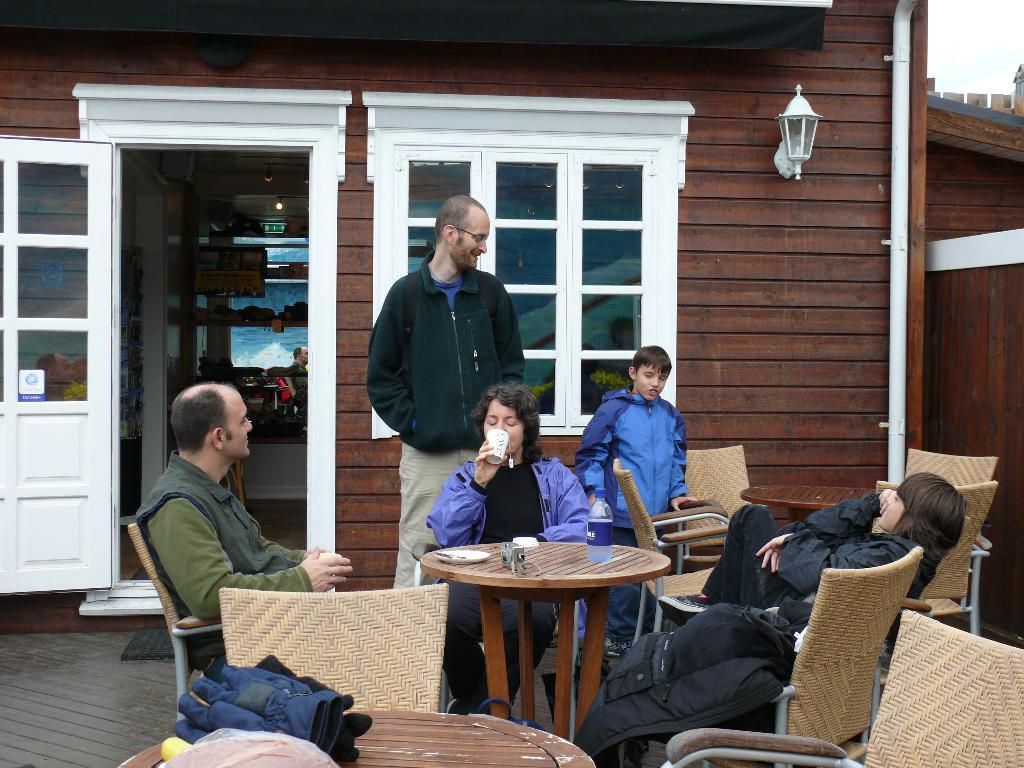What are the people in the image doing? The people in the image are sitting on chairs. Can you describe the man in the image? There is a man standing in the image. What items can be seen on the table in the image? There are gloves on the table in the image. What can be seen in the background of the image? There is a building visible at the back side of the image. Can you see any bread floating in the ocean in the image? There is no ocean or bread present in the image. 